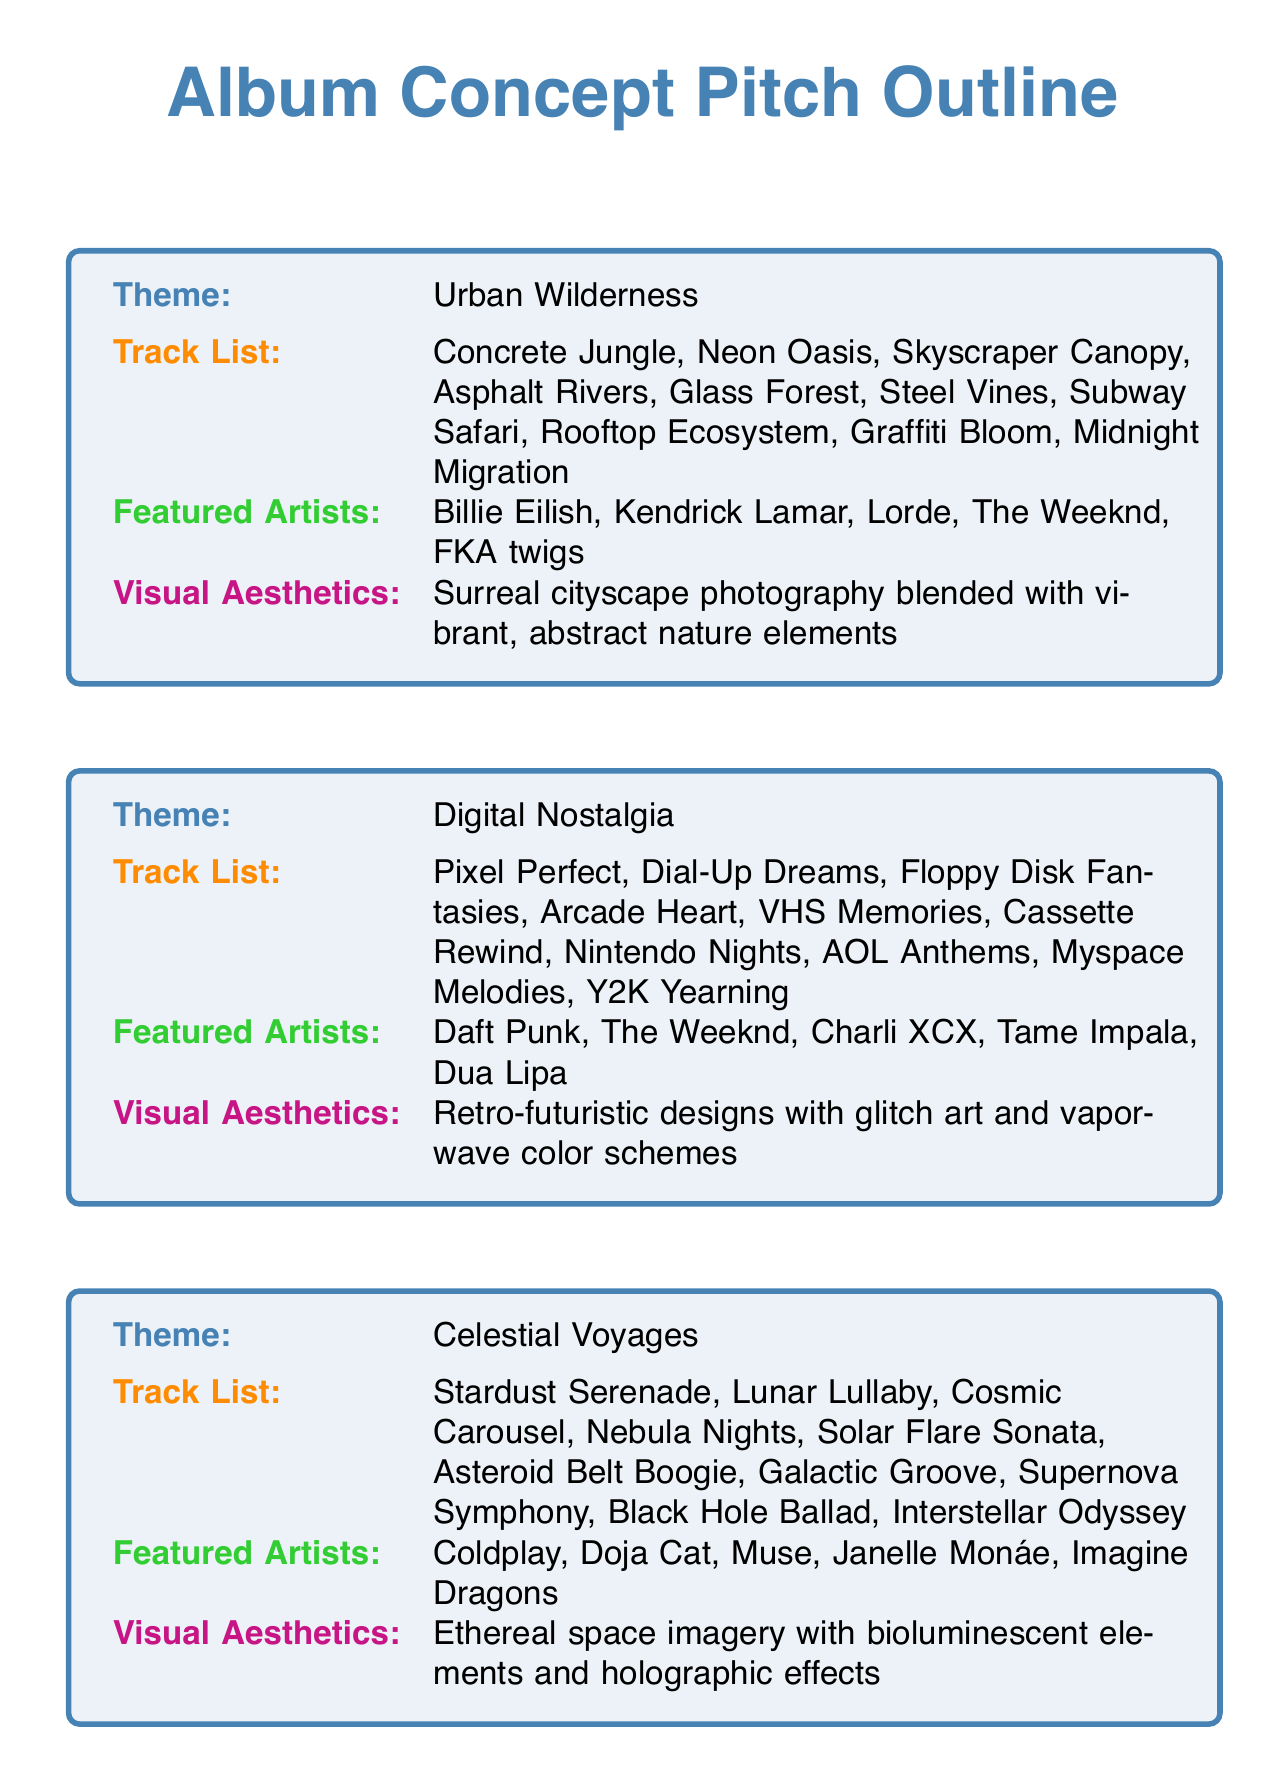What is the theme of the first album concept? The theme of the first album concept can be found in the document's first entry.
Answer: Urban Wilderness How many tracks are listed in the "Digital Nostalgia" album? The number of tracks can be counted directly in the "Digital Nostalgia" section of the document.
Answer: 10 Name one featured artist from the "Celestial Voyages" album. The document lists artists featured in each album concept, and "Celestial Voyages" includes several names.
Answer: Coldplay What visual aesthetic is associated with "Emotional Spectrum"? The visual aesthetic description for "Emotional Spectrum" is provided in the respective section of the document.
Answer: Abstract color field paintings with expressive brushstrokes and color gradients Which album has the theme of food? The theme of Culinary Rhythms is explicitly mentioned among the album concepts.
Answer: Culinary Rhythms How many unique themes are presented in the document? The number of unique themes corresponds to the number of album concepts listed in the document.
Answer: 5 List a track from the "Culinary Rhythms" album. Tracks are listed individually under each album concept; one can be directly cited from the "Culinary Rhythms" section.
Answer: Sizzling Salsa Which artist appears in both "Digital Nostalgia" and "Celestial Voyages"? The occurrence of artists can be checked across different album concepts to identify any repeats.
Answer: The Weeknd What color scheme is described for the "Digital Nostalgia" aesthetic? The description for visual aesthetics gives clues about the colors used in the theme.
Answer: Glitch art and vaporwave color schemes 